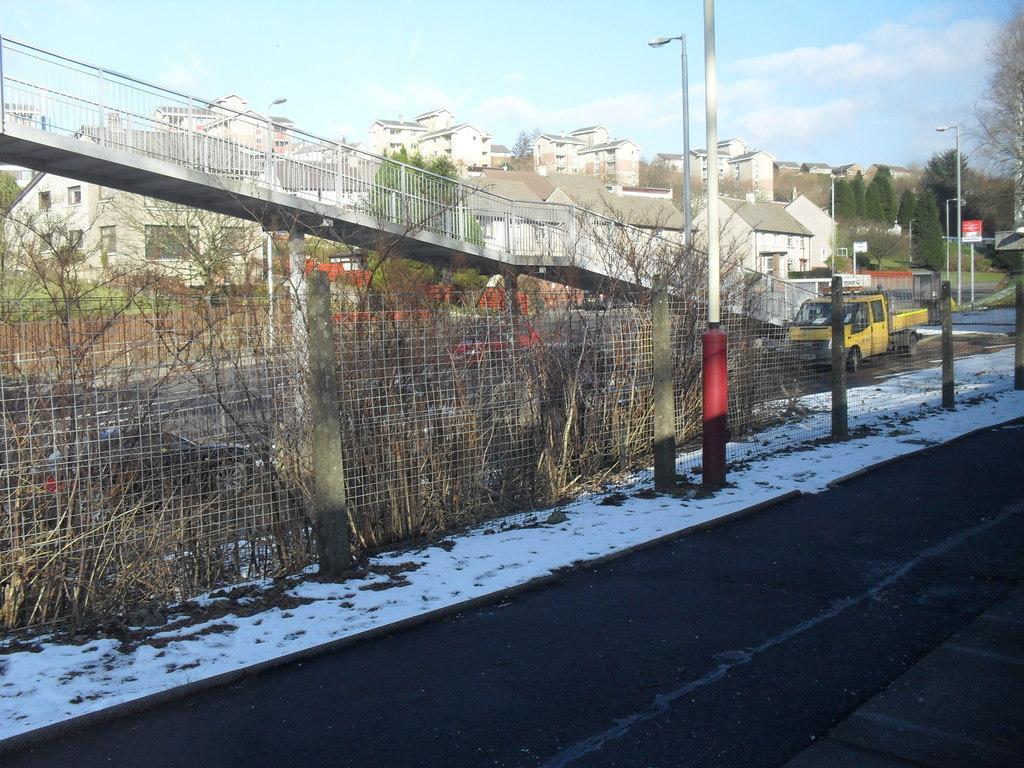Can you describe this image briefly? In the picture we can see a road beside it, we can see a path with snow and some poles and a railing and behind the railing we can see a vehicle on the path which is yellow in color and behind it we can see houses, buildings, and sky with clouds. 